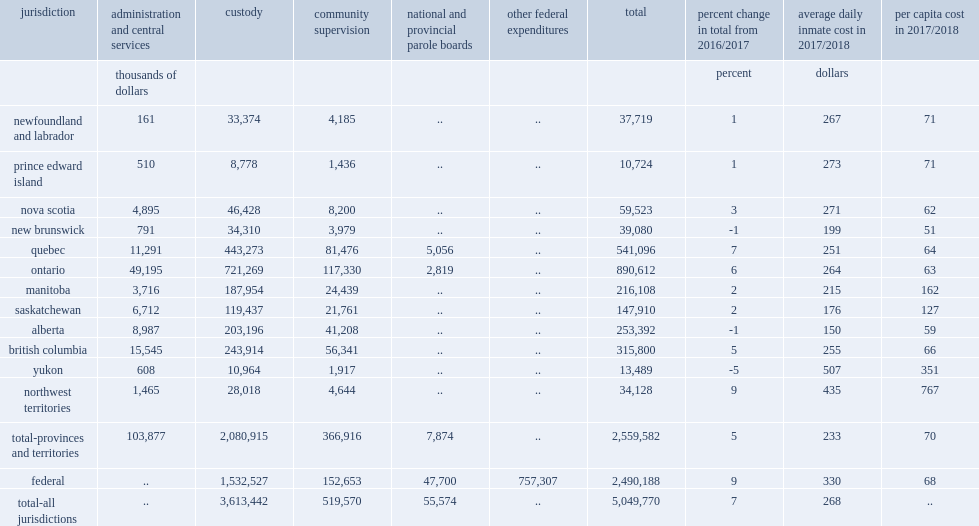What was the operating expenditures for adult correctional services in canada in 2017/2018? 5049770.0. What was the change in operating expenditures for adult correctional services in canada from 2016/2017 after adjusting for inflation? 7.0. What were per capita expenditures for provincial/territorial correctional services in 2017/2018? 70.0. What were per capita expenditures for federal correctional services in 2017/2018? 68.0. What was custodial services expenditures from reporting provinces and territories in 2017/2018? 2080915.0. What was the percentage of correctional expenditures from reporting provinces and territories that custodial services expenditures accounted for in 2017/2018? 0.81299. What was community supervision expenditures from reporting provinces and territories in 2017/2018? 366916.0. What was the percentage of total expenditures community supervision expenditures accounted for from reporting provinces and territories in 2017/2018? 0.14335. 